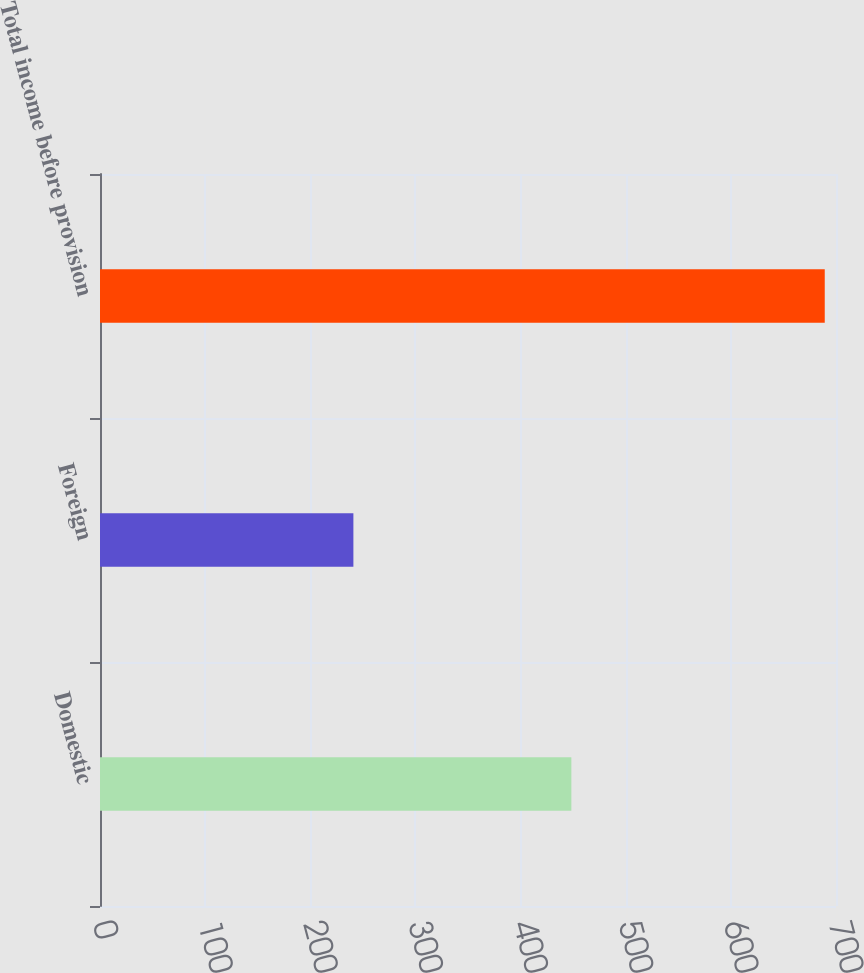Convert chart. <chart><loc_0><loc_0><loc_500><loc_500><bar_chart><fcel>Domestic<fcel>Foreign<fcel>Total income before provision<nl><fcel>448.3<fcel>241<fcel>689.3<nl></chart> 